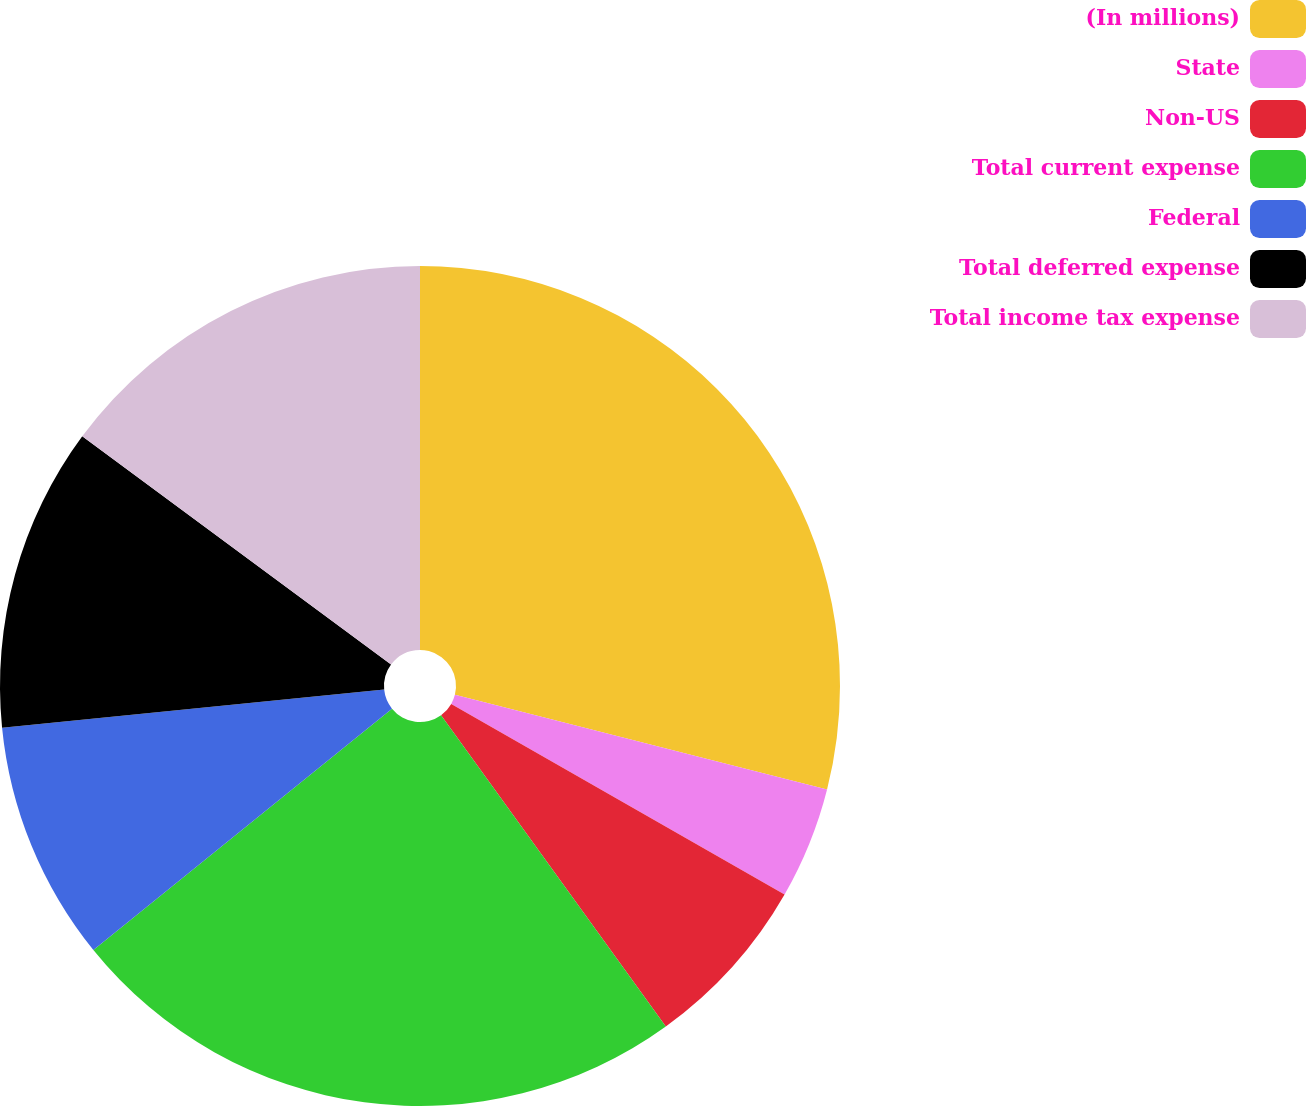<chart> <loc_0><loc_0><loc_500><loc_500><pie_chart><fcel>(In millions)<fcel>State<fcel>Non-US<fcel>Total current expense<fcel>Federal<fcel>Total deferred expense<fcel>Total income tax expense<nl><fcel>28.96%<fcel>4.31%<fcel>6.78%<fcel>24.13%<fcel>9.24%<fcel>11.71%<fcel>14.87%<nl></chart> 